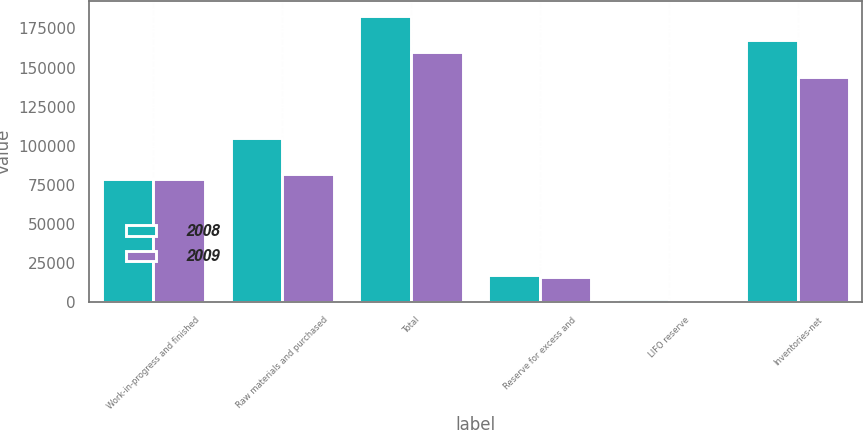Convert chart to OTSL. <chart><loc_0><loc_0><loc_500><loc_500><stacked_bar_chart><ecel><fcel>Work-in-progress and finished<fcel>Raw materials and purchased<fcel>Total<fcel>Reserve for excess and<fcel>LIFO reserve<fcel>Inventories-net<nl><fcel>2008<fcel>78423<fcel>104729<fcel>183152<fcel>17018<fcel>1632<fcel>167766<nl><fcel>2009<fcel>78467<fcel>81750<fcel>160217<fcel>15862<fcel>241<fcel>144114<nl></chart> 